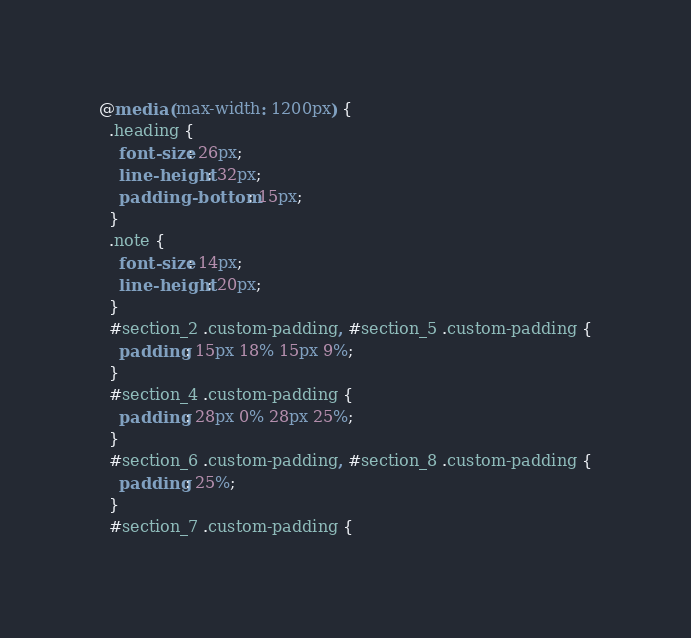Convert code to text. <code><loc_0><loc_0><loc_500><loc_500><_CSS_>@media (max-width: 1200px) {
  .heading {
    font-size: 26px;
    line-height: 32px;
    padding-bottom: 15px;
  }
  .note {
    font-size: 14px;
    line-height: 20px;
  }
  #section_2 .custom-padding, #section_5 .custom-padding {
    padding: 15px 18% 15px 9%;
  }
  #section_4 .custom-padding {
    padding: 28px 0% 28px 25%;
  }
  #section_6 .custom-padding, #section_8 .custom-padding {
    padding: 25%;
  }
  #section_7 .custom-padding {</code> 